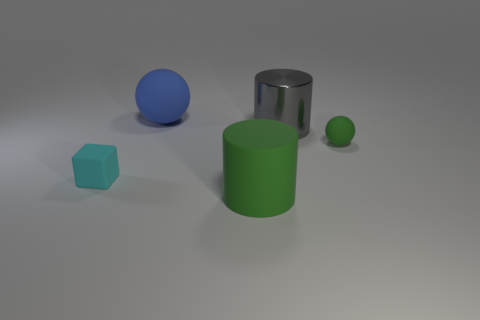Add 4 large balls. How many objects exist? 9 Subtract all cylinders. How many objects are left? 3 Add 1 gray matte objects. How many gray matte objects exist? 1 Subtract 0 green blocks. How many objects are left? 5 Subtract all big matte objects. Subtract all blue things. How many objects are left? 2 Add 1 gray metallic things. How many gray metallic things are left? 2 